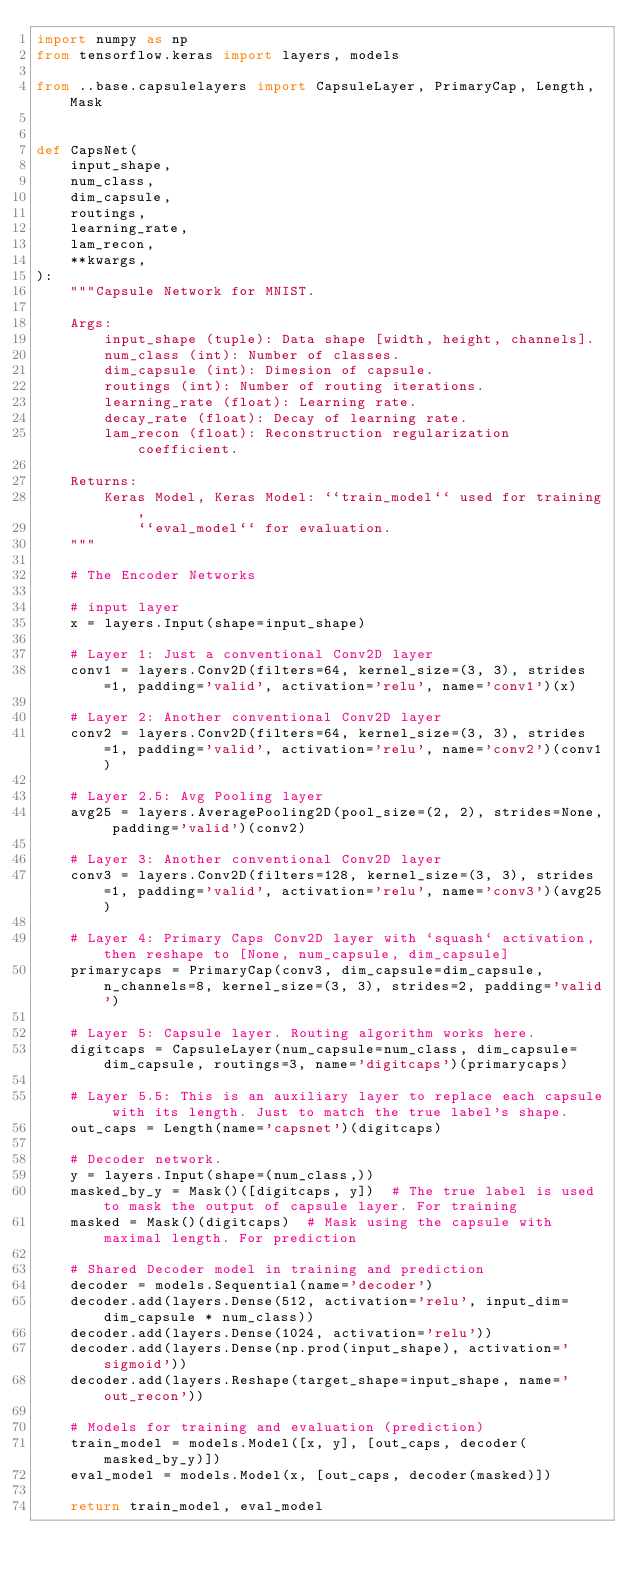Convert code to text. <code><loc_0><loc_0><loc_500><loc_500><_Python_>import numpy as np
from tensorflow.keras import layers, models

from ..base.capsulelayers import CapsuleLayer, PrimaryCap, Length, Mask


def CapsNet(
    input_shape,
    num_class,
    dim_capsule,
    routings,
    learning_rate,
    lam_recon,
    **kwargs,
):
    """Capsule Network for MNIST.

    Args:
        input_shape (tuple): Data shape [width, height, channels].
        num_class (int): Number of classes.
        dim_capsule (int): Dimesion of capsule.
        routings (int): Number of routing iterations.
        learning_rate (float): Learning rate.
        decay_rate (float): Decay of learning rate.
        lam_recon (float): Reconstruction regularization coefficient.

    Returns:
        Keras Model, Keras Model: ``train_model`` used for training,
            ``eval_model`` for evaluation.
    """

    # The Encoder Networks

    # input layer
    x = layers.Input(shape=input_shape)

    # Layer 1: Just a conventional Conv2D layer
    conv1 = layers.Conv2D(filters=64, kernel_size=(3, 3), strides=1, padding='valid', activation='relu', name='conv1')(x)

    # Layer 2: Another conventional Conv2D layer
    conv2 = layers.Conv2D(filters=64, kernel_size=(3, 3), strides=1, padding='valid', activation='relu', name='conv2')(conv1)

    # Layer 2.5: Avg Pooling layer
    avg25 = layers.AveragePooling2D(pool_size=(2, 2), strides=None, padding='valid')(conv2)

    # Layer 3: Another conventional Conv2D layer
    conv3 = layers.Conv2D(filters=128, kernel_size=(3, 3), strides=1, padding='valid', activation='relu', name='conv3')(avg25)

    # Layer 4: Primary Caps Conv2D layer with `squash` activation, then reshape to [None, num_capsule, dim_capsule]
    primarycaps = PrimaryCap(conv3, dim_capsule=dim_capsule, n_channels=8, kernel_size=(3, 3), strides=2, padding='valid')

    # Layer 5: Capsule layer. Routing algorithm works here.
    digitcaps = CapsuleLayer(num_capsule=num_class, dim_capsule=dim_capsule, routings=3, name='digitcaps')(primarycaps)

    # Layer 5.5: This is an auxiliary layer to replace each capsule with its length. Just to match the true label's shape.
    out_caps = Length(name='capsnet')(digitcaps)

    # Decoder network.
    y = layers.Input(shape=(num_class,))
    masked_by_y = Mask()([digitcaps, y])  # The true label is used to mask the output of capsule layer. For training
    masked = Mask()(digitcaps)  # Mask using the capsule with maximal length. For prediction

    # Shared Decoder model in training and prediction
    decoder = models.Sequential(name='decoder')
    decoder.add(layers.Dense(512, activation='relu', input_dim=dim_capsule * num_class))
    decoder.add(layers.Dense(1024, activation='relu'))
    decoder.add(layers.Dense(np.prod(input_shape), activation='sigmoid'))
    decoder.add(layers.Reshape(target_shape=input_shape, name='out_recon'))

    # Models for training and evaluation (prediction)
    train_model = models.Model([x, y], [out_caps, decoder(masked_by_y)])
    eval_model = models.Model(x, [out_caps, decoder(masked)])

    return train_model, eval_model
</code> 